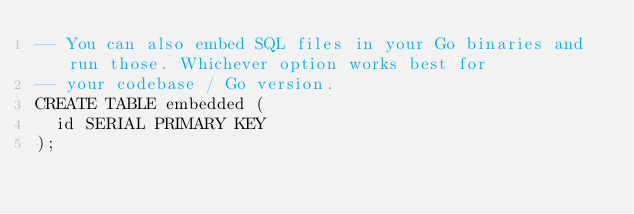<code> <loc_0><loc_0><loc_500><loc_500><_SQL_>-- You can also embed SQL files in your Go binaries and run those. Whichever option works best for
-- your codebase / Go version.
CREATE TABLE embedded (
  id SERIAL PRIMARY KEY
);
</code> 